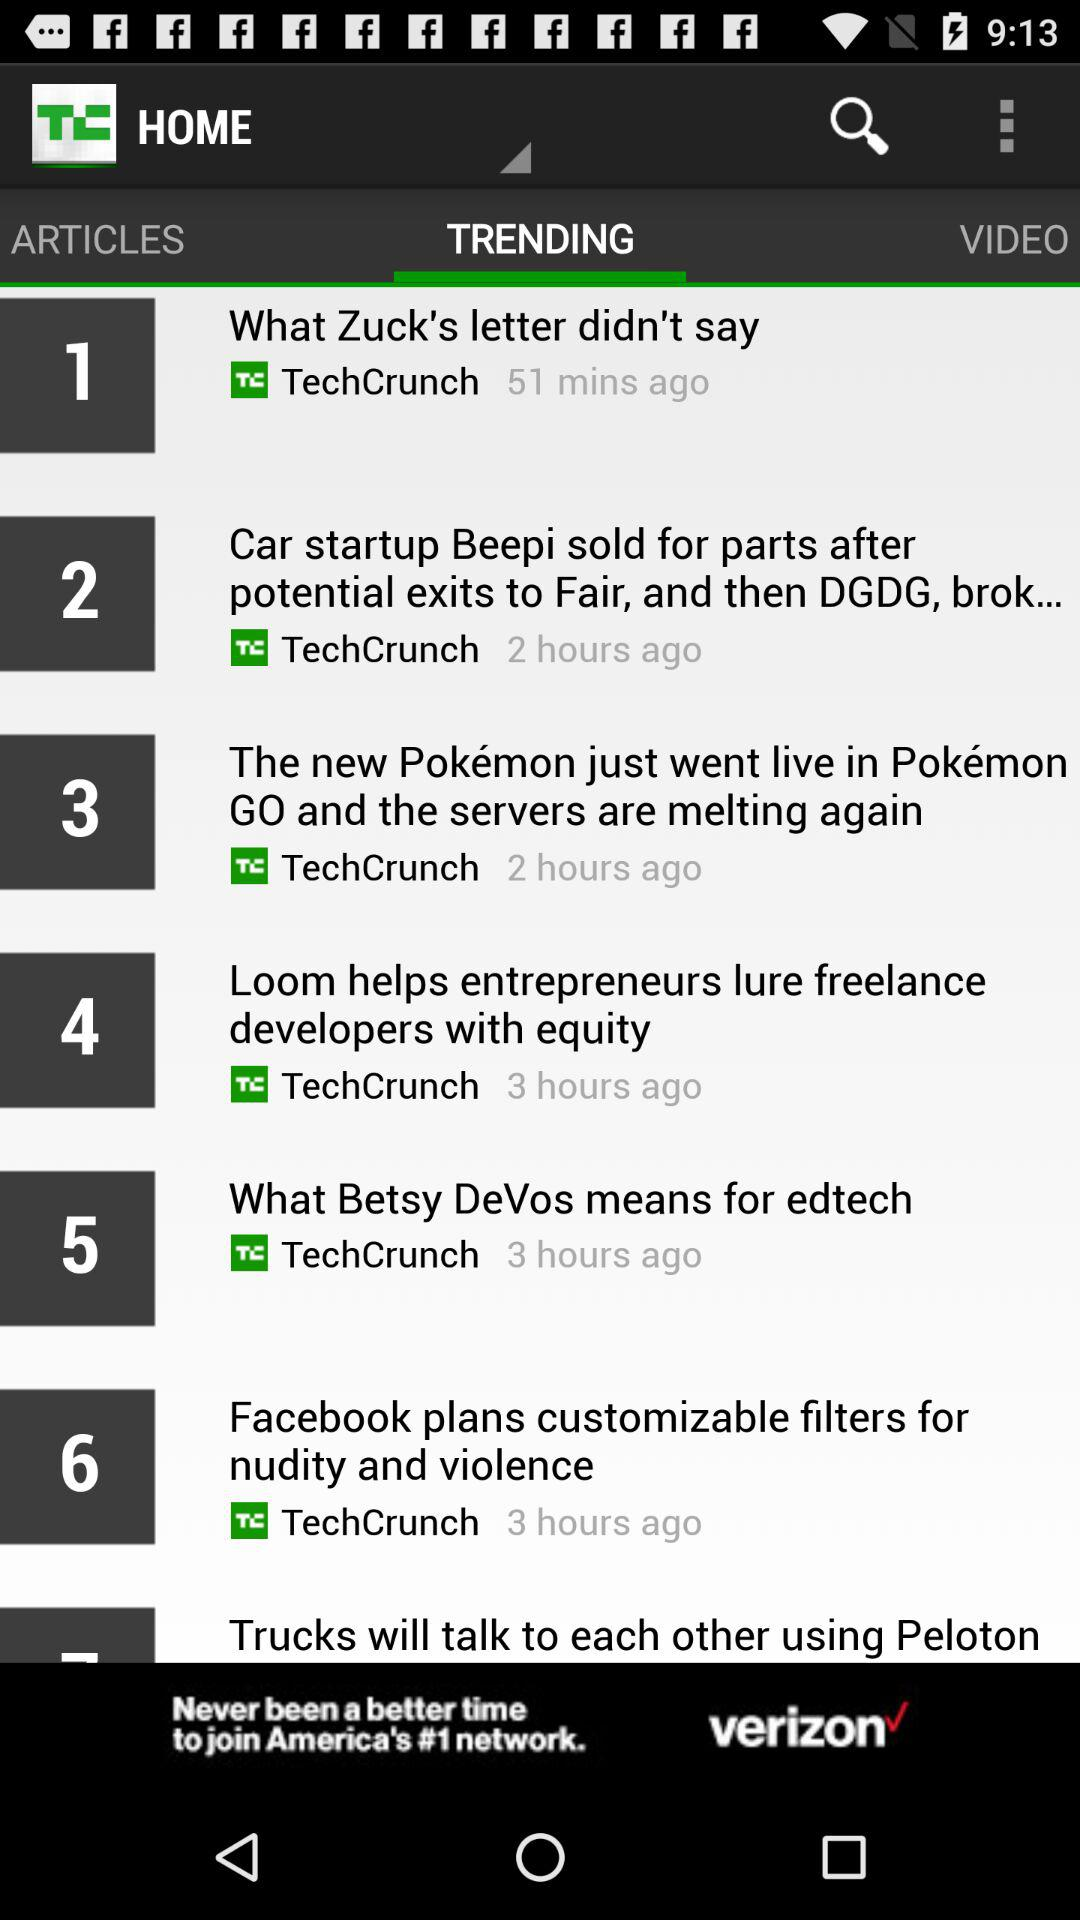What's the post time of the number 2 trending article? The post time is "2 hours ago". 